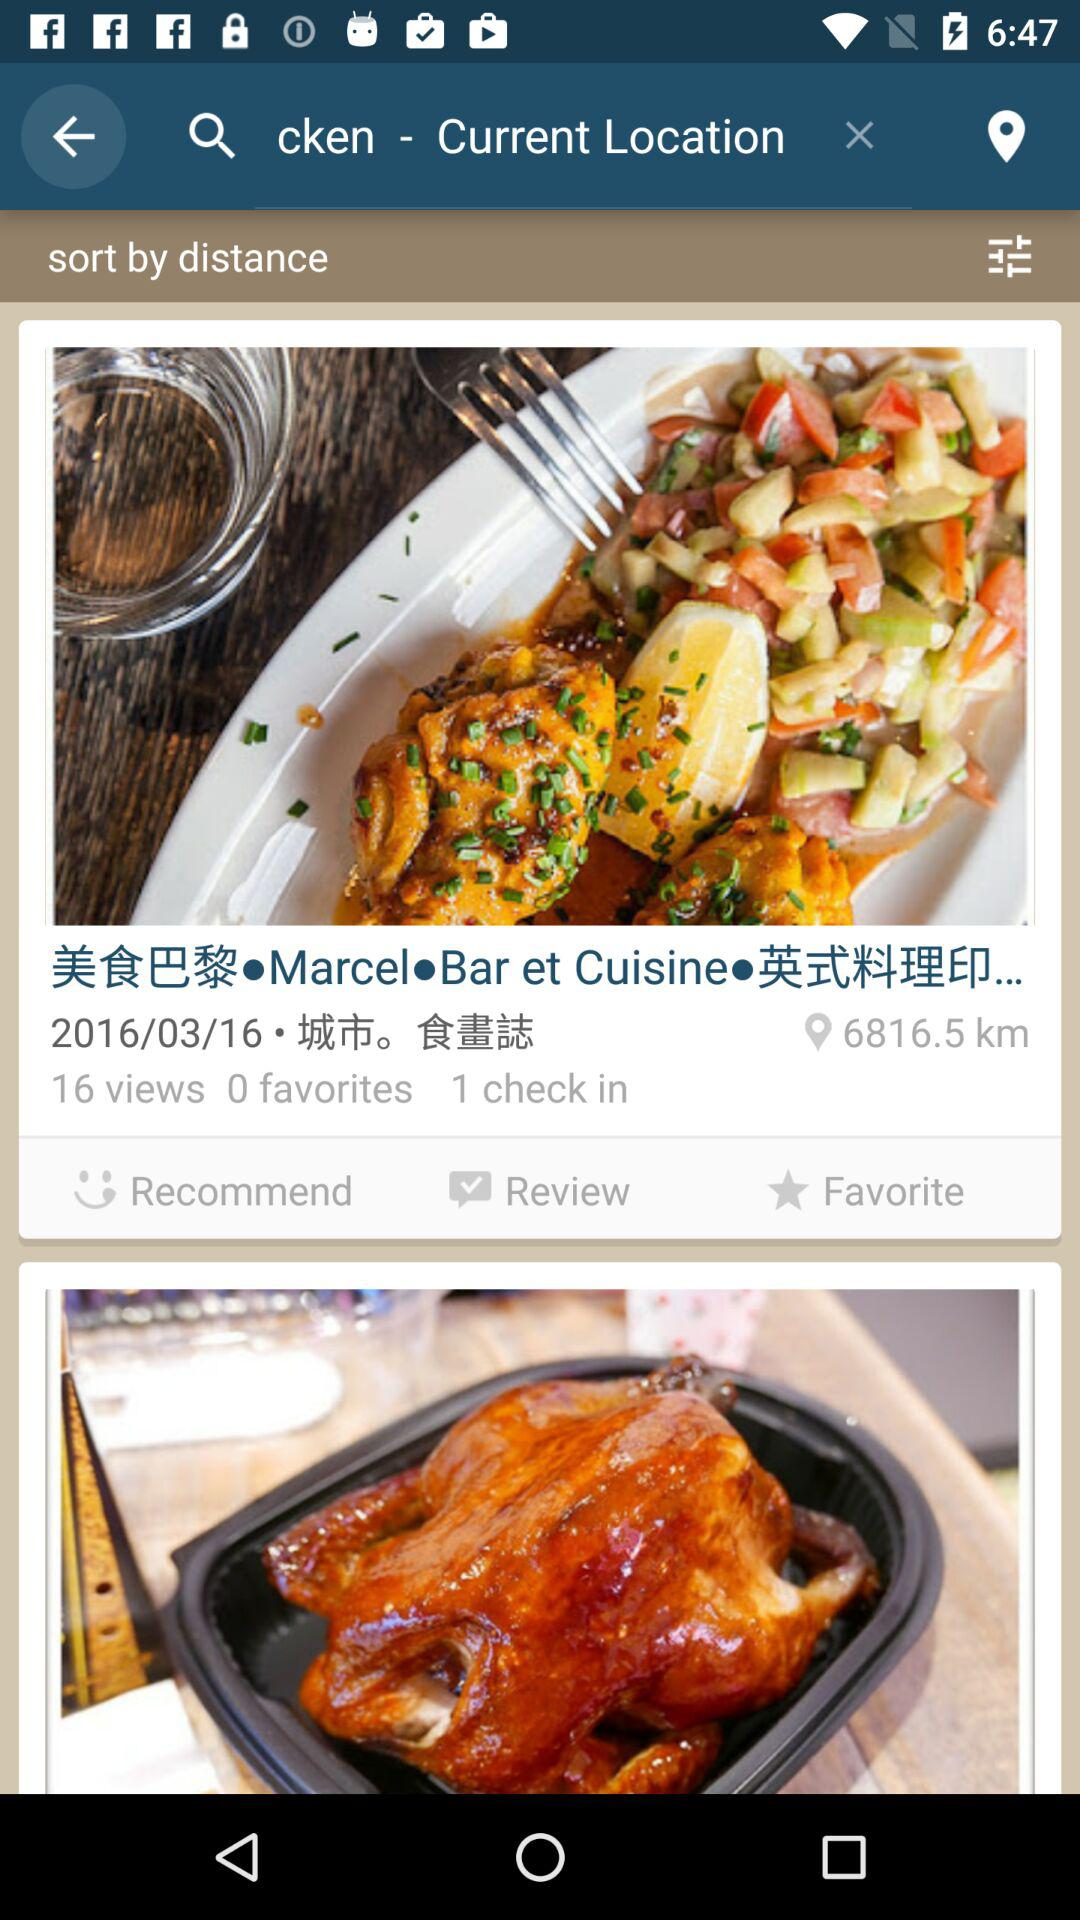How many check-ins are there? There is 1 check-in. 